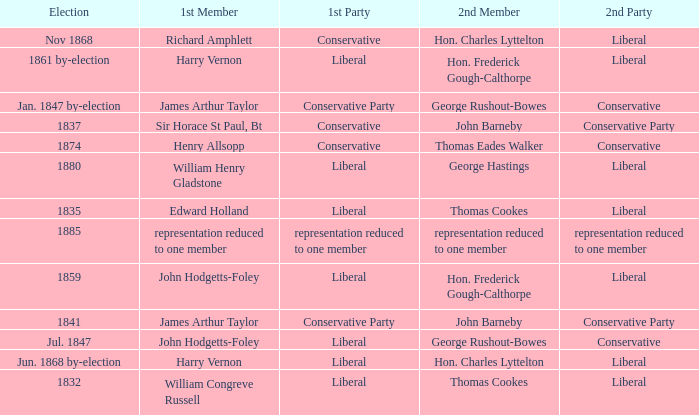What was the 2nd Party that had the 2nd Member John Barneby, when the 1st Party was Conservative? Conservative Party. 